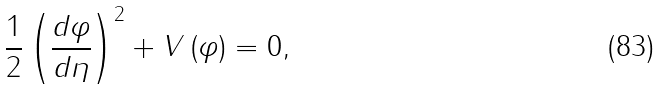<formula> <loc_0><loc_0><loc_500><loc_500>\frac { 1 } { 2 } \left ( { \frac { d \varphi } { d \eta } } \right ) ^ { 2 } + V \left ( \varphi \right ) = 0 ,</formula> 